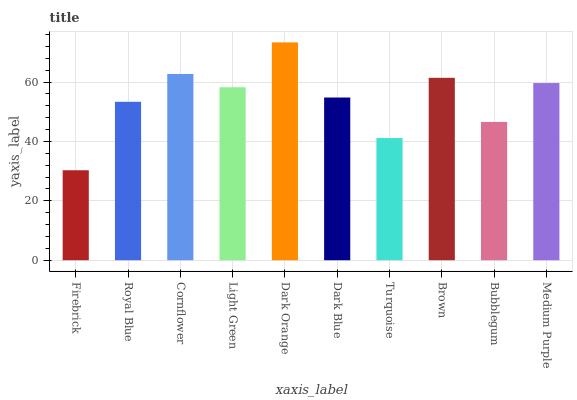Is Firebrick the minimum?
Answer yes or no. Yes. Is Dark Orange the maximum?
Answer yes or no. Yes. Is Royal Blue the minimum?
Answer yes or no. No. Is Royal Blue the maximum?
Answer yes or no. No. Is Royal Blue greater than Firebrick?
Answer yes or no. Yes. Is Firebrick less than Royal Blue?
Answer yes or no. Yes. Is Firebrick greater than Royal Blue?
Answer yes or no. No. Is Royal Blue less than Firebrick?
Answer yes or no. No. Is Light Green the high median?
Answer yes or no. Yes. Is Dark Blue the low median?
Answer yes or no. Yes. Is Brown the high median?
Answer yes or no. No. Is Brown the low median?
Answer yes or no. No. 